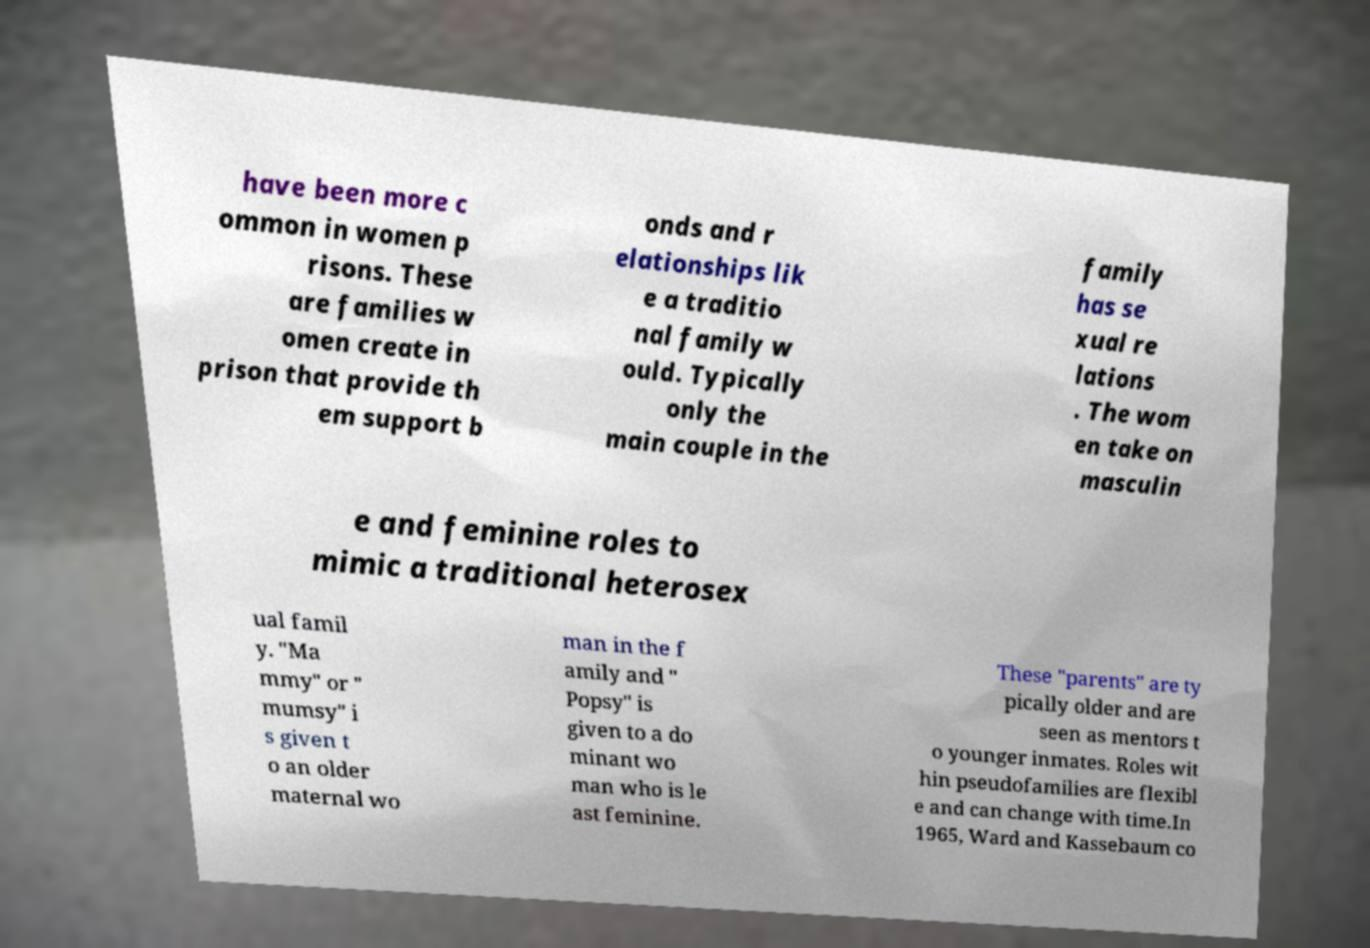I need the written content from this picture converted into text. Can you do that? have been more c ommon in women p risons. These are families w omen create in prison that provide th em support b onds and r elationships lik e a traditio nal family w ould. Typically only the main couple in the family has se xual re lations . The wom en take on masculin e and feminine roles to mimic a traditional heterosex ual famil y. "Ma mmy" or " mumsy" i s given t o an older maternal wo man in the f amily and " Popsy" is given to a do minant wo man who is le ast feminine. These "parents" are ty pically older and are seen as mentors t o younger inmates. Roles wit hin pseudofamilies are flexibl e and can change with time.In 1965, Ward and Kassebaum co 